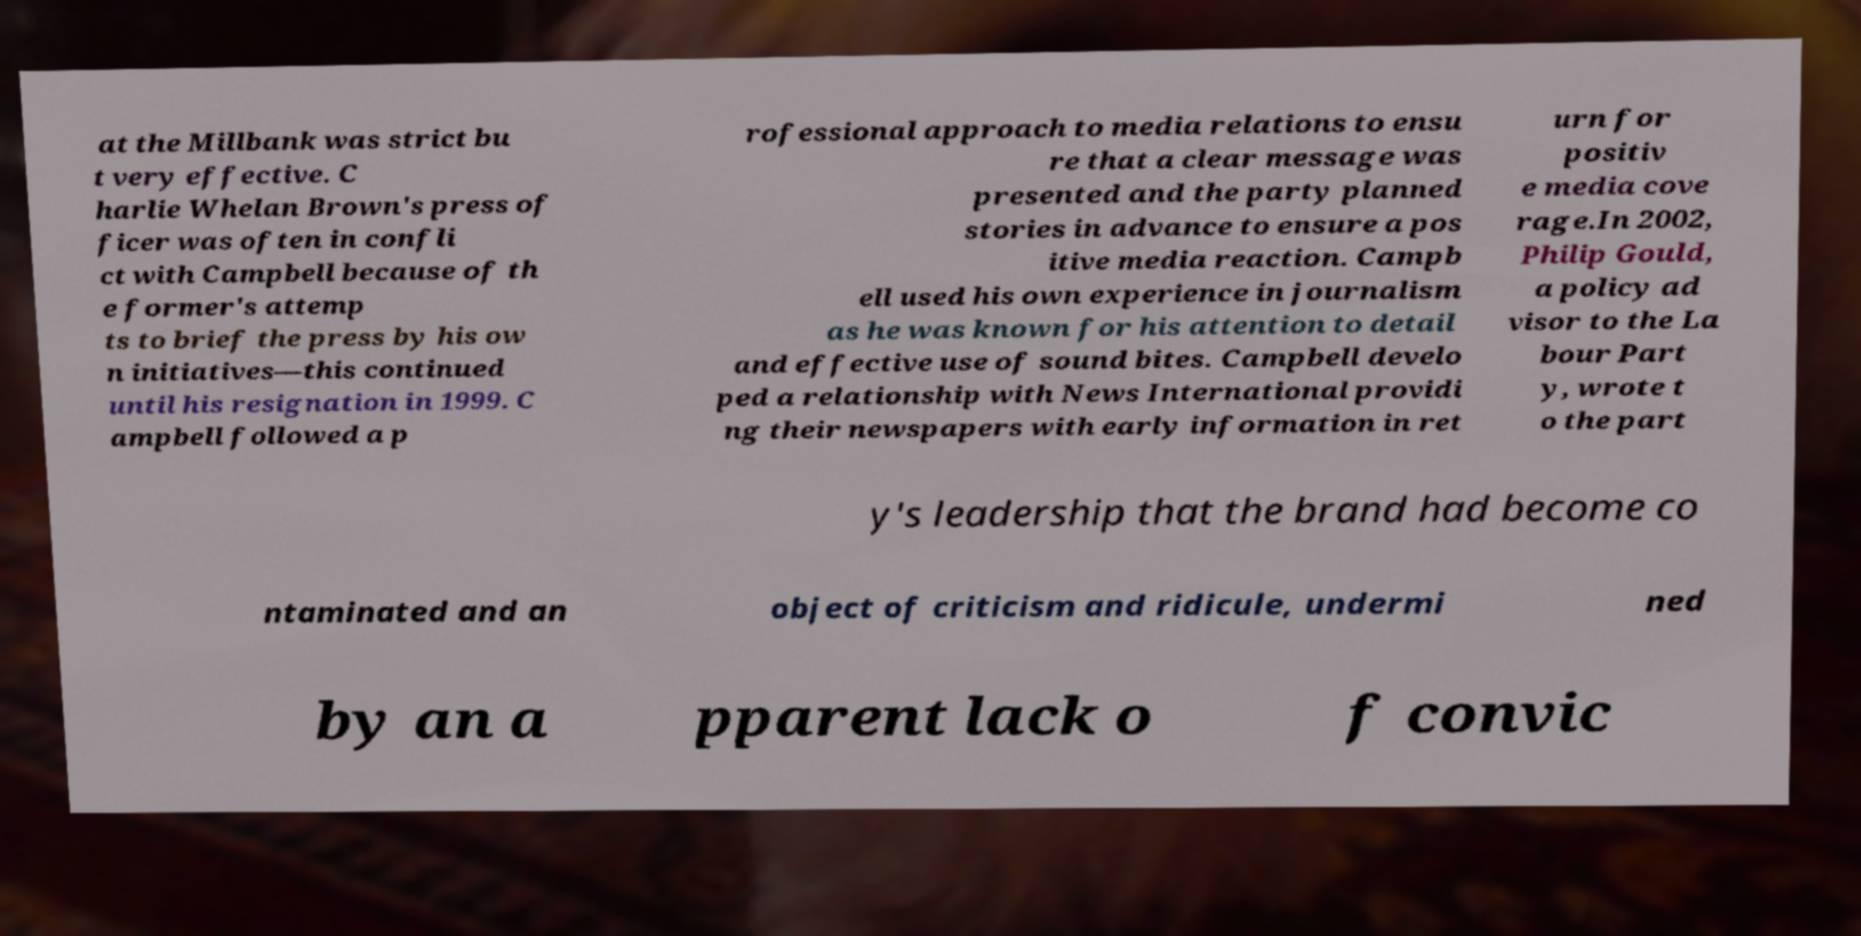Can you accurately transcribe the text from the provided image for me? at the Millbank was strict bu t very effective. C harlie Whelan Brown's press of ficer was often in confli ct with Campbell because of th e former's attemp ts to brief the press by his ow n initiatives—this continued until his resignation in 1999. C ampbell followed a p rofessional approach to media relations to ensu re that a clear message was presented and the party planned stories in advance to ensure a pos itive media reaction. Campb ell used his own experience in journalism as he was known for his attention to detail and effective use of sound bites. Campbell develo ped a relationship with News International providi ng their newspapers with early information in ret urn for positiv e media cove rage.In 2002, Philip Gould, a policy ad visor to the La bour Part y, wrote t o the part y's leadership that the brand had become co ntaminated and an object of criticism and ridicule, undermi ned by an a pparent lack o f convic 